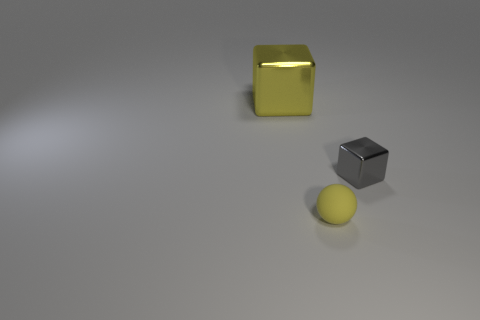Are there any other things that have the same material as the small ball?
Offer a terse response. No. Is the color of the ball the same as the big metal cube?
Your answer should be very brief. Yes. There is a rubber sphere; what number of rubber objects are left of it?
Your answer should be compact. 0. Are there more small yellow cylinders than small yellow rubber spheres?
Your response must be concise. No. What is the shape of the object that is both left of the small metallic thing and right of the large metallic object?
Ensure brevity in your answer.  Sphere. Is there a red rubber cube?
Your answer should be very brief. No. What material is the yellow object that is the same shape as the tiny gray metallic thing?
Keep it short and to the point. Metal. What is the shape of the shiny thing in front of the metal thing that is behind the shiny block on the right side of the big yellow shiny cube?
Give a very brief answer. Cube. What is the material of the large block that is the same color as the small matte thing?
Your answer should be very brief. Metal. What number of large yellow metal things are the same shape as the gray metal thing?
Your answer should be very brief. 1. 